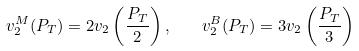<formula> <loc_0><loc_0><loc_500><loc_500>v _ { 2 } ^ { M } ( P _ { T } ) = 2 v _ { 2 } \left ( \frac { P _ { T } } { 2 } \right ) , \quad v _ { 2 } ^ { B } ( P _ { T } ) = 3 v _ { 2 } \left ( \frac { P _ { T } } { 3 } \right )</formula> 